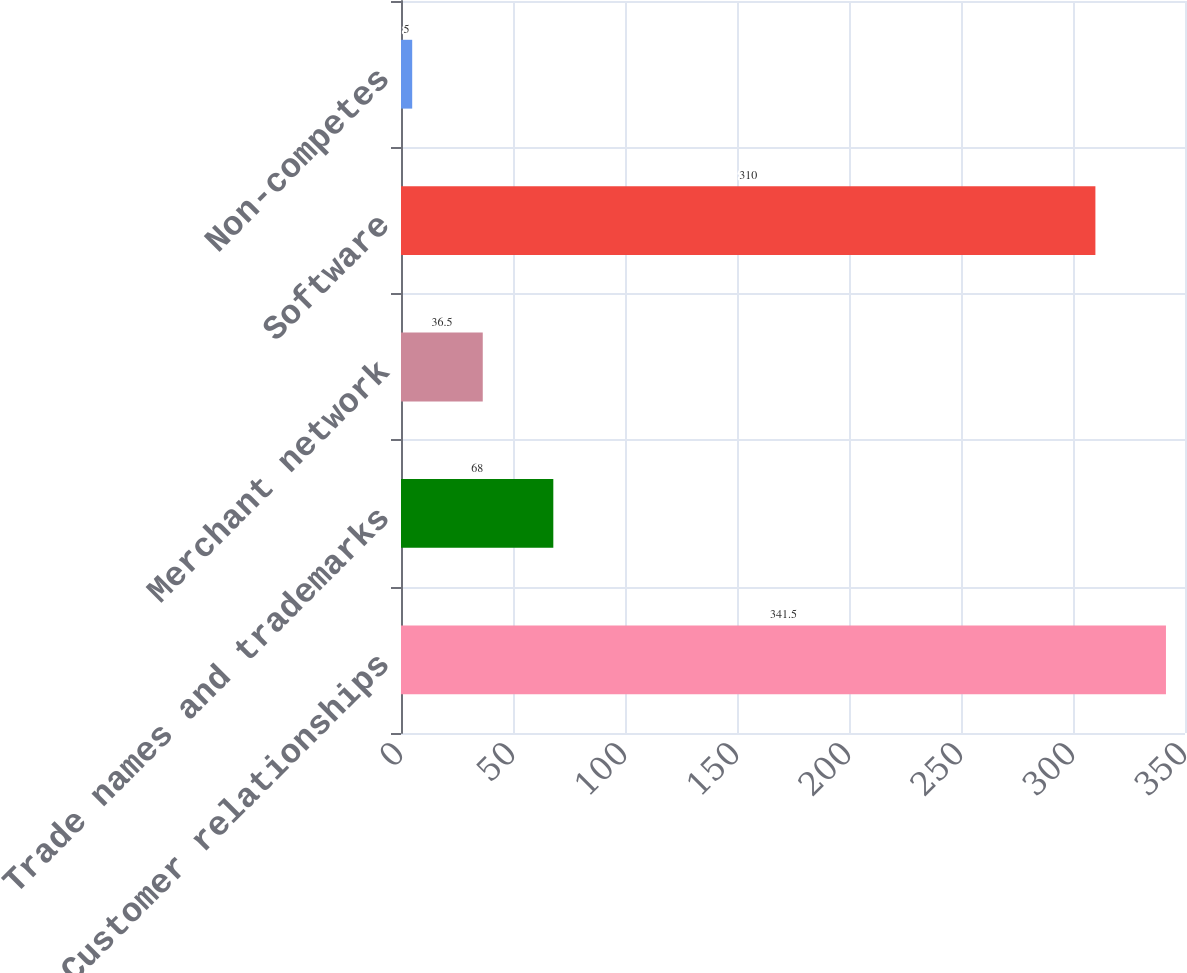Convert chart to OTSL. <chart><loc_0><loc_0><loc_500><loc_500><bar_chart><fcel>Customer relationships<fcel>Trade names and trademarks<fcel>Merchant network<fcel>Software<fcel>Non-competes<nl><fcel>341.5<fcel>68<fcel>36.5<fcel>310<fcel>5<nl></chart> 